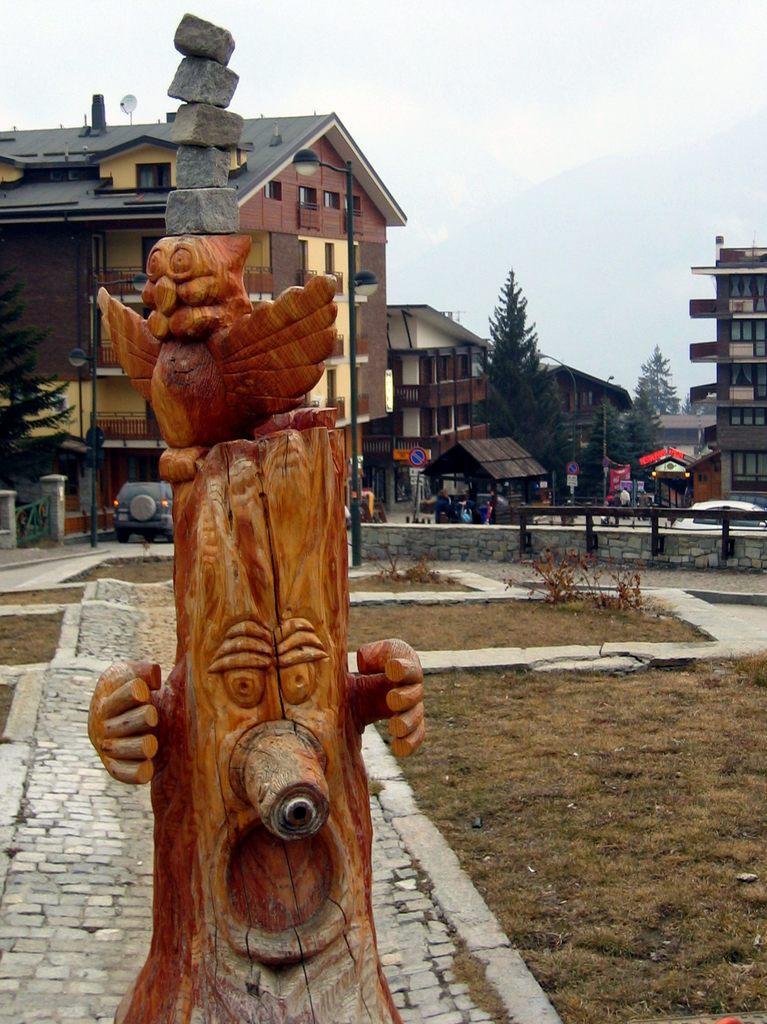Please provide a concise description of this image. In this image, It looks like a wooden sculpture. I can see the rocks, which are placed one upon the other on the wooden sculpture. I can see the grass and the pathway. In the background, these are the buildings, trees and vehicles. This is the sky. It looks like a street light. 